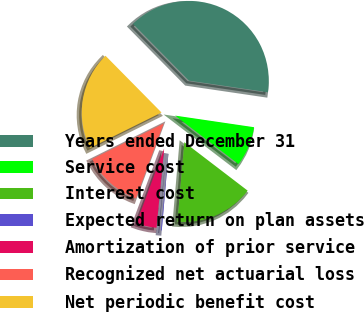Convert chart to OTSL. <chart><loc_0><loc_0><loc_500><loc_500><pie_chart><fcel>Years ended December 31<fcel>Service cost<fcel>Interest cost<fcel>Expected return on plan assets<fcel>Amortization of prior service<fcel>Recognized net actuarial loss<fcel>Net periodic benefit cost<nl><fcel>39.72%<fcel>8.07%<fcel>15.98%<fcel>0.16%<fcel>4.11%<fcel>12.03%<fcel>19.94%<nl></chart> 